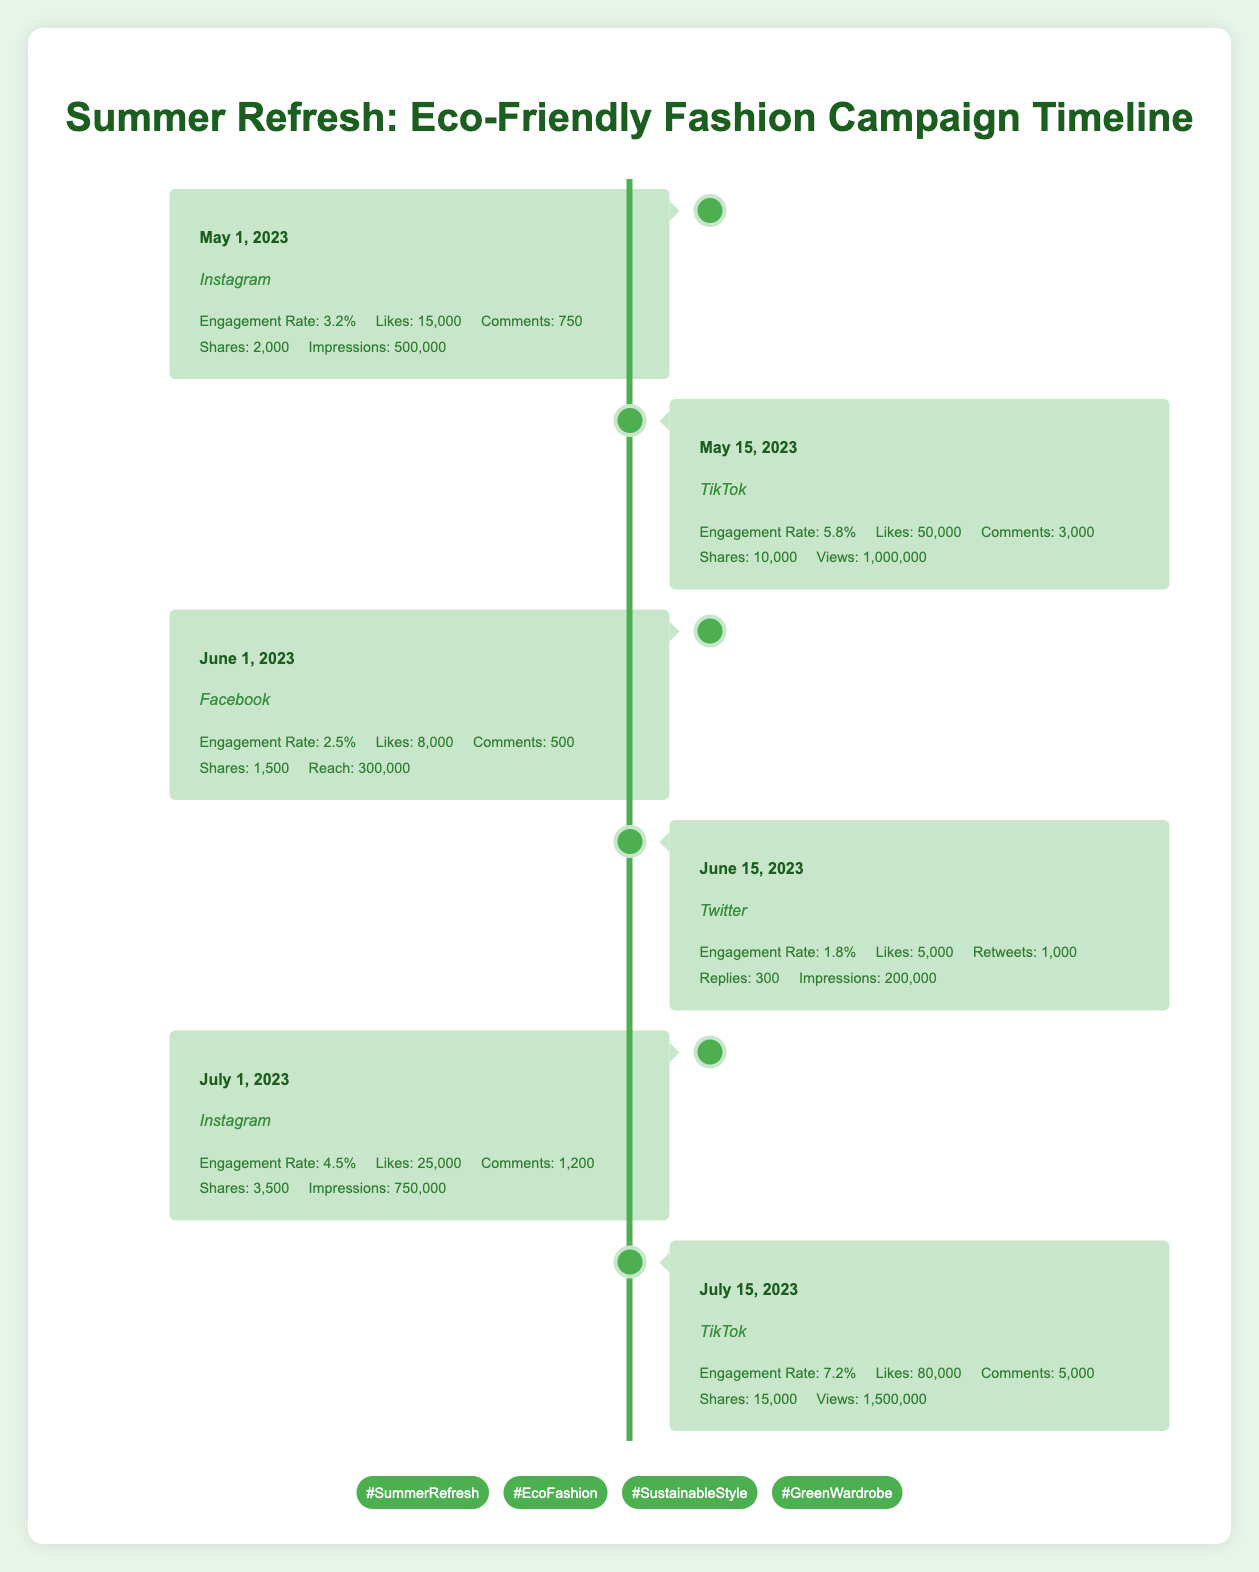What was the engagement rate for TikTok on July 15, 2023? The engagement rate for TikTok on July 15, 2023, can be found directly in the timeline data listed under that date. It states the engagement rate is 7.2%.
Answer: 7.2% Which platform had the highest number of likes on May 15, 2023? Looking at the timeline entries, on May 15, 2023, TikTok had 50,000 likes, which is more than the likes recorded for Instagram (15,000) and Facebook (8,000) on their respective dates. Therefore, it had the highest number of likes on that date.
Answer: TikTok What is the total number of shares collected on Instagram during the campaign? From the timeline, Instagram collected shares of 2,000 (May 1) and 3,500 (July 1). Adding those two values gives 2,000 + 3,500 = 5,500.
Answer: 5,500 Did Facebook have a higher engagement rate compared to Twitter on June 15, 2023? The engagement rate for Facebook on June 1, 2023, is 2.5%, while for Twitter on June 15, 2023, it is 1.8%. Since 2.5% is greater than 1.8%, thus Facebook had a higher engagement rate compared to Twitter.
Answer: Yes What is the average engagement rate for TikTok during the campaign? TikTok engagement rates are 5.8% (May 15) and 7.2% (July 15). To find the average, add these two rates: 5.8 + 7.2 = 13.0. Then divide by 2, resulting in 13.0 / 2 = 6.5%.
Answer: 6.5% Which platform resulted in the highest number of comments on July 15, 2023? On July 15, 2023, TikTok had 5,000 comments, which is recorded in its timeline entry. This is higher than any other platform's comments because other entries do not list July 15, but even their highest numbers on relevant dates are lower than 5,000.
Answer: TikTok How many more views did TikTok have on July 15, 2023, compared to its previous entry on May 15, 2023? On July 15, 2023, TikTok had 1,500,000 views while the previous entry on May 15 had 1,000,000 views. To find the difference, subtract the earlier figure from the latter: 1,500,000 - 1,000,000 = 500,000.
Answer: 500,000 Was the total number of likes across all platforms lower than 200,000 by July 15, 2023? Reviewing the likes across all entries till July 15: Instagram had 15,000 + 25,000 (July 1), TikTok had 50,000 + 80,000 (July 15), Facebook had 8,000, and Twitter had 5,000. Adding them gives 15,000 + 25,000 + 50,000 + 80,000 + 8,000 + 5,000 = 183,000, which is less than 200,000.
Answer: Yes What was the reach for Facebook on June 1, 2023? The reach for Facebook on that date is directly stated in the timeline data, and it reports a reach of 300,000.
Answer: 300,000 